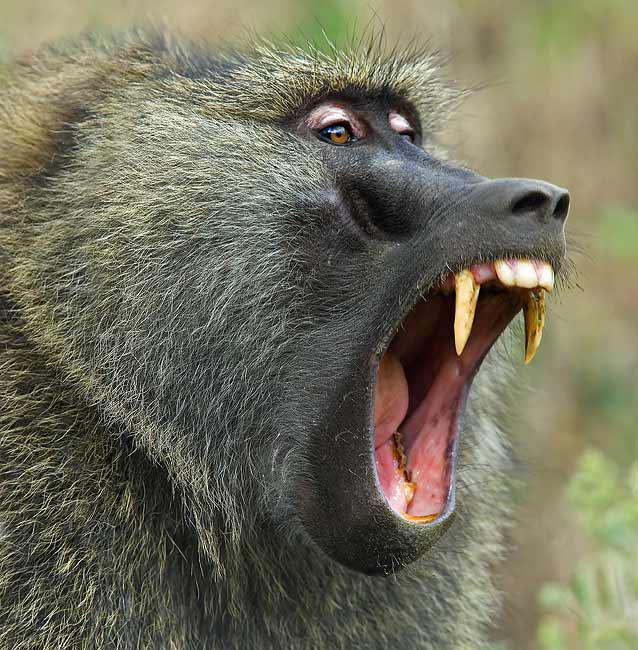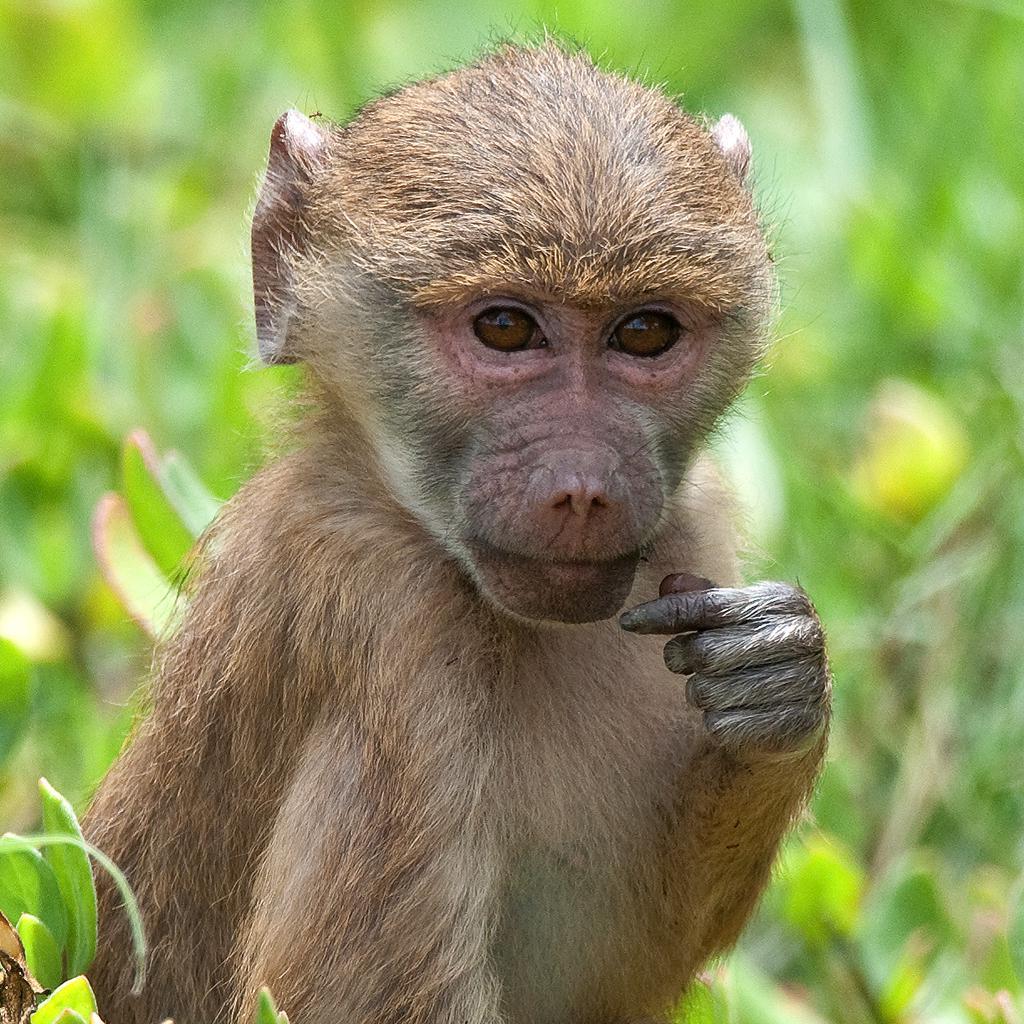The first image is the image on the left, the second image is the image on the right. Given the left and right images, does the statement "Teeth are visible in the baboons in each image." hold true? Answer yes or no. No. 